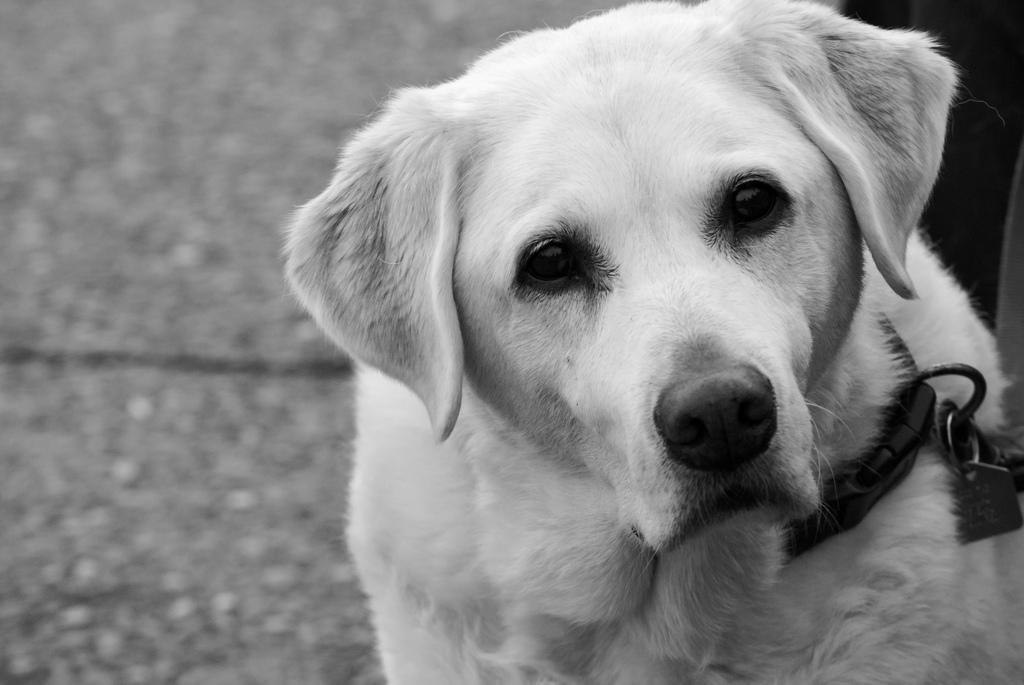What type of animal is in the picture? There is a white dog in the picture. What is the dog wearing around its neck? The dog has a belt around its neck. What surface is visible in the picture? There is a floor visible in the picture. How many balls can be seen rolling on the floor in the image? There are no balls visible in the image; it only features a white dog with a belt around its neck and a floor. 